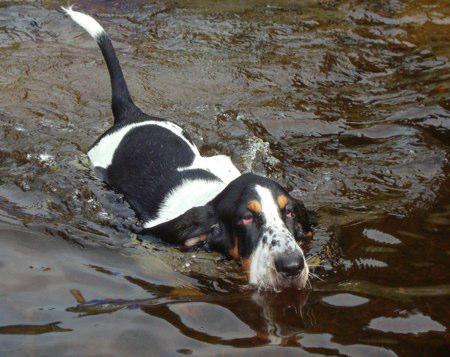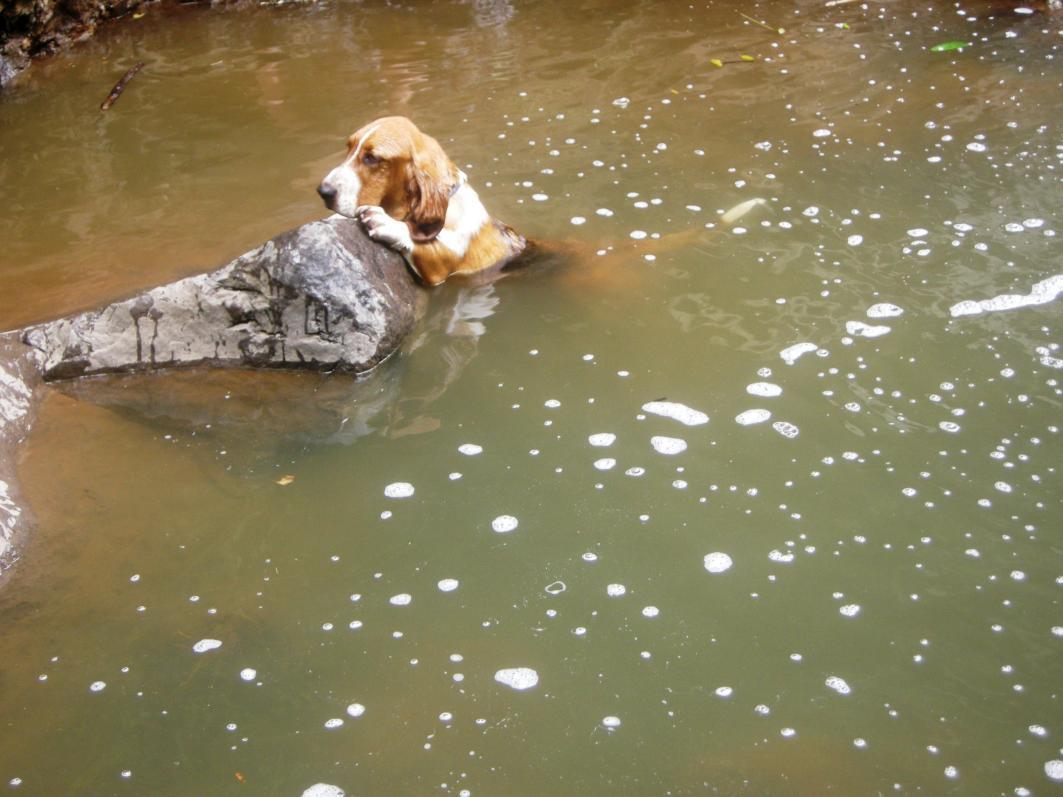The first image is the image on the left, the second image is the image on the right. Given the left and right images, does the statement "A basset hound is wearing a bright red-orange life vest in a scene that contains water." hold true? Answer yes or no. No. The first image is the image on the left, the second image is the image on the right. Given the left and right images, does the statement "The dog in the image on the left is wearing a life jacket." hold true? Answer yes or no. No. 